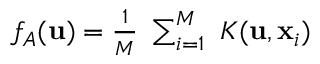<formula> <loc_0><loc_0><loc_500><loc_500>\begin{array} { r } { f _ { A } ( u ) = \frac { 1 } { M } \sum _ { i = 1 } ^ { M } K ( u , x _ { i } ) } \end{array}</formula> 